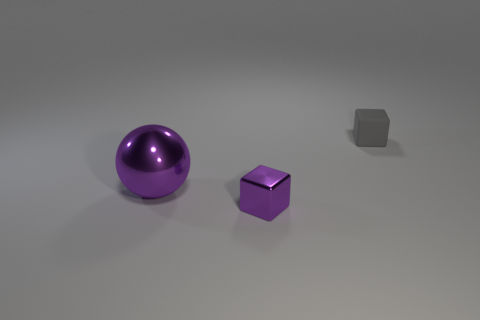How many cylinders are either rubber things or metal objects?
Make the answer very short. 0. What color is the object that is the same size as the shiny cube?
Provide a succinct answer. Gray. How many objects are both right of the big purple ball and on the left side of the small gray rubber block?
Offer a very short reply. 1. What material is the big purple thing?
Keep it short and to the point. Metal. What number of objects are big purple metal objects or small objects?
Provide a succinct answer. 3. There is a cube in front of the big metallic ball; is it the same size as the purple metal sphere in front of the gray matte cube?
Your answer should be compact. No. What number of other things are there of the same size as the metal ball?
Your answer should be very brief. 0. How many things are either small purple shiny blocks in front of the large purple metallic ball or metal objects left of the small metallic cube?
Offer a terse response. 2. Does the big purple thing have the same material as the block that is behind the big purple ball?
Make the answer very short. No. What number of other things are there of the same shape as the large object?
Your answer should be very brief. 0. 